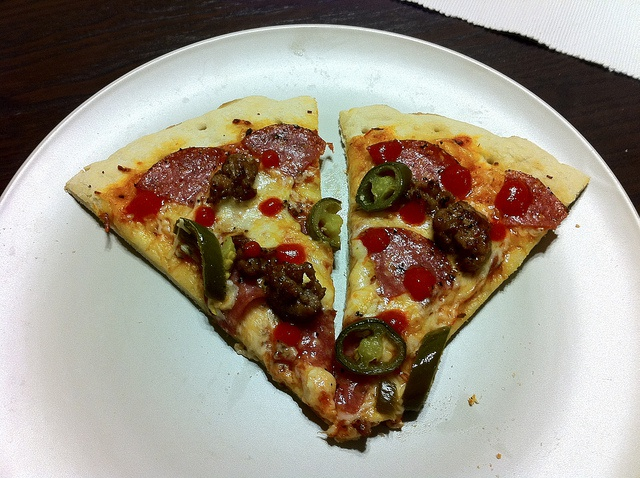Describe the objects in this image and their specific colors. I can see a pizza in black, maroon, olive, and khaki tones in this image. 